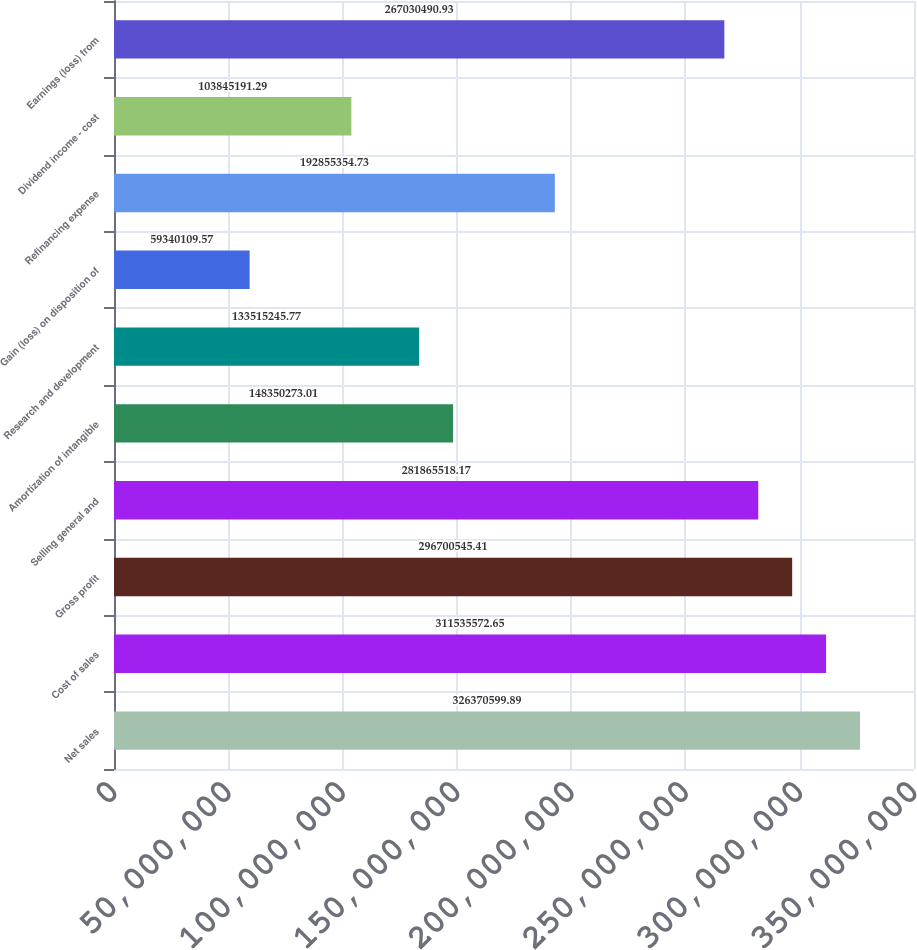Convert chart. <chart><loc_0><loc_0><loc_500><loc_500><bar_chart><fcel>Net sales<fcel>Cost of sales<fcel>Gross profit<fcel>Selling general and<fcel>Amortization of intangible<fcel>Research and development<fcel>Gain (loss) on disposition of<fcel>Refinancing expense<fcel>Dividend income - cost<fcel>Earnings (loss) from<nl><fcel>3.26371e+08<fcel>3.11536e+08<fcel>2.96701e+08<fcel>2.81866e+08<fcel>1.4835e+08<fcel>1.33515e+08<fcel>5.93401e+07<fcel>1.92855e+08<fcel>1.03845e+08<fcel>2.6703e+08<nl></chart> 